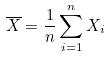<formula> <loc_0><loc_0><loc_500><loc_500>\overline { X } = \frac { 1 } { n } \sum _ { i = 1 } ^ { n } X _ { i }</formula> 